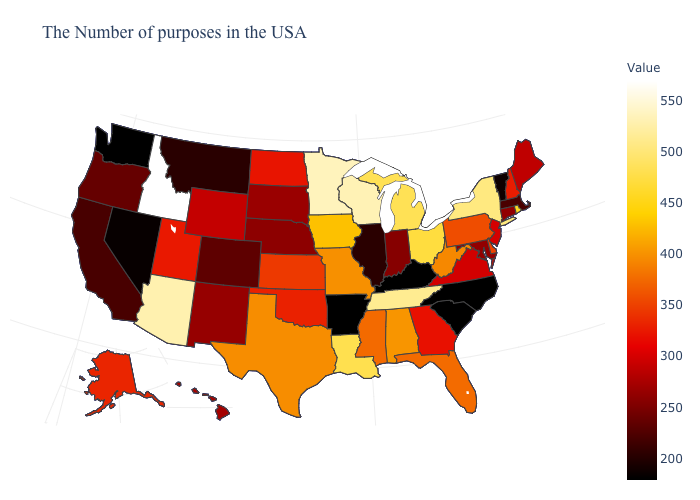Among the states that border Minnesota , which have the lowest value?
Short answer required. South Dakota. Which states have the lowest value in the South?
Write a very short answer. North Carolina, South Carolina, Kentucky, Arkansas. Is the legend a continuous bar?
Keep it brief. Yes. Which states have the highest value in the USA?
Answer briefly. Idaho. 